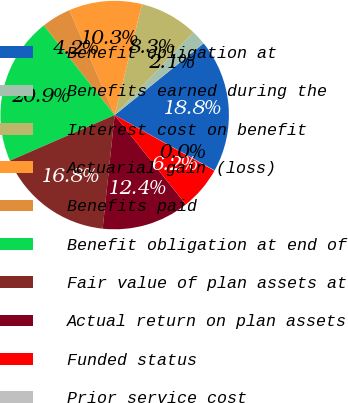<chart> <loc_0><loc_0><loc_500><loc_500><pie_chart><fcel>Benefit obligation at<fcel>Benefits earned during the<fcel>Interest cost on benefit<fcel>Actuarial gain (loss)<fcel>Benefits paid<fcel>Benefit obligation at end of<fcel>Fair value of plan assets at<fcel>Actual return on plan assets<fcel>Funded status<fcel>Prior service cost<nl><fcel>18.84%<fcel>2.1%<fcel>8.27%<fcel>10.33%<fcel>4.16%<fcel>20.89%<fcel>16.78%<fcel>12.38%<fcel>6.21%<fcel>0.04%<nl></chart> 